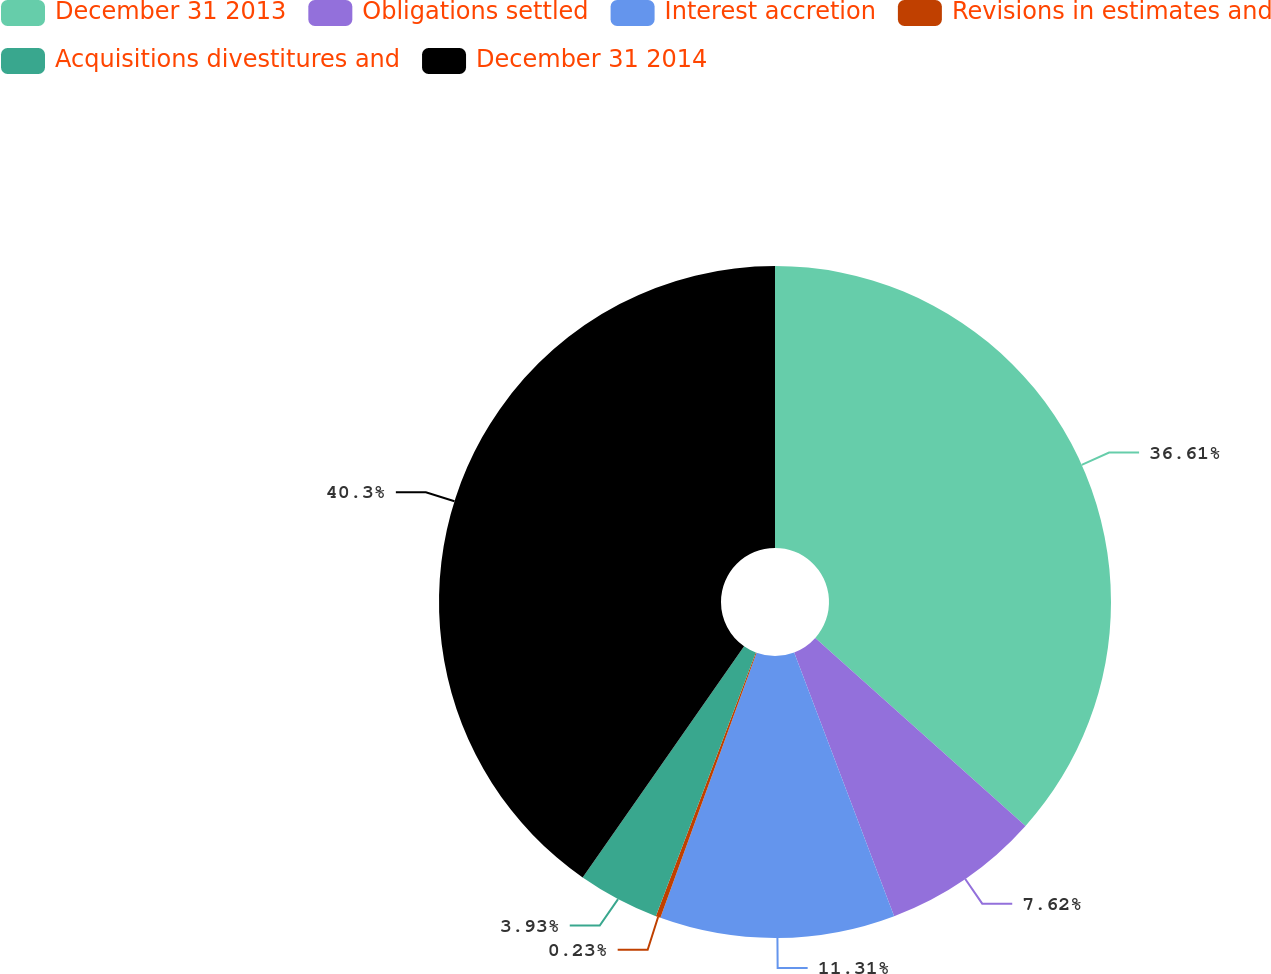Convert chart to OTSL. <chart><loc_0><loc_0><loc_500><loc_500><pie_chart><fcel>December 31 2013<fcel>Obligations settled<fcel>Interest accretion<fcel>Revisions in estimates and<fcel>Acquisitions divestitures and<fcel>December 31 2014<nl><fcel>36.61%<fcel>7.62%<fcel>11.31%<fcel>0.23%<fcel>3.93%<fcel>40.3%<nl></chart> 